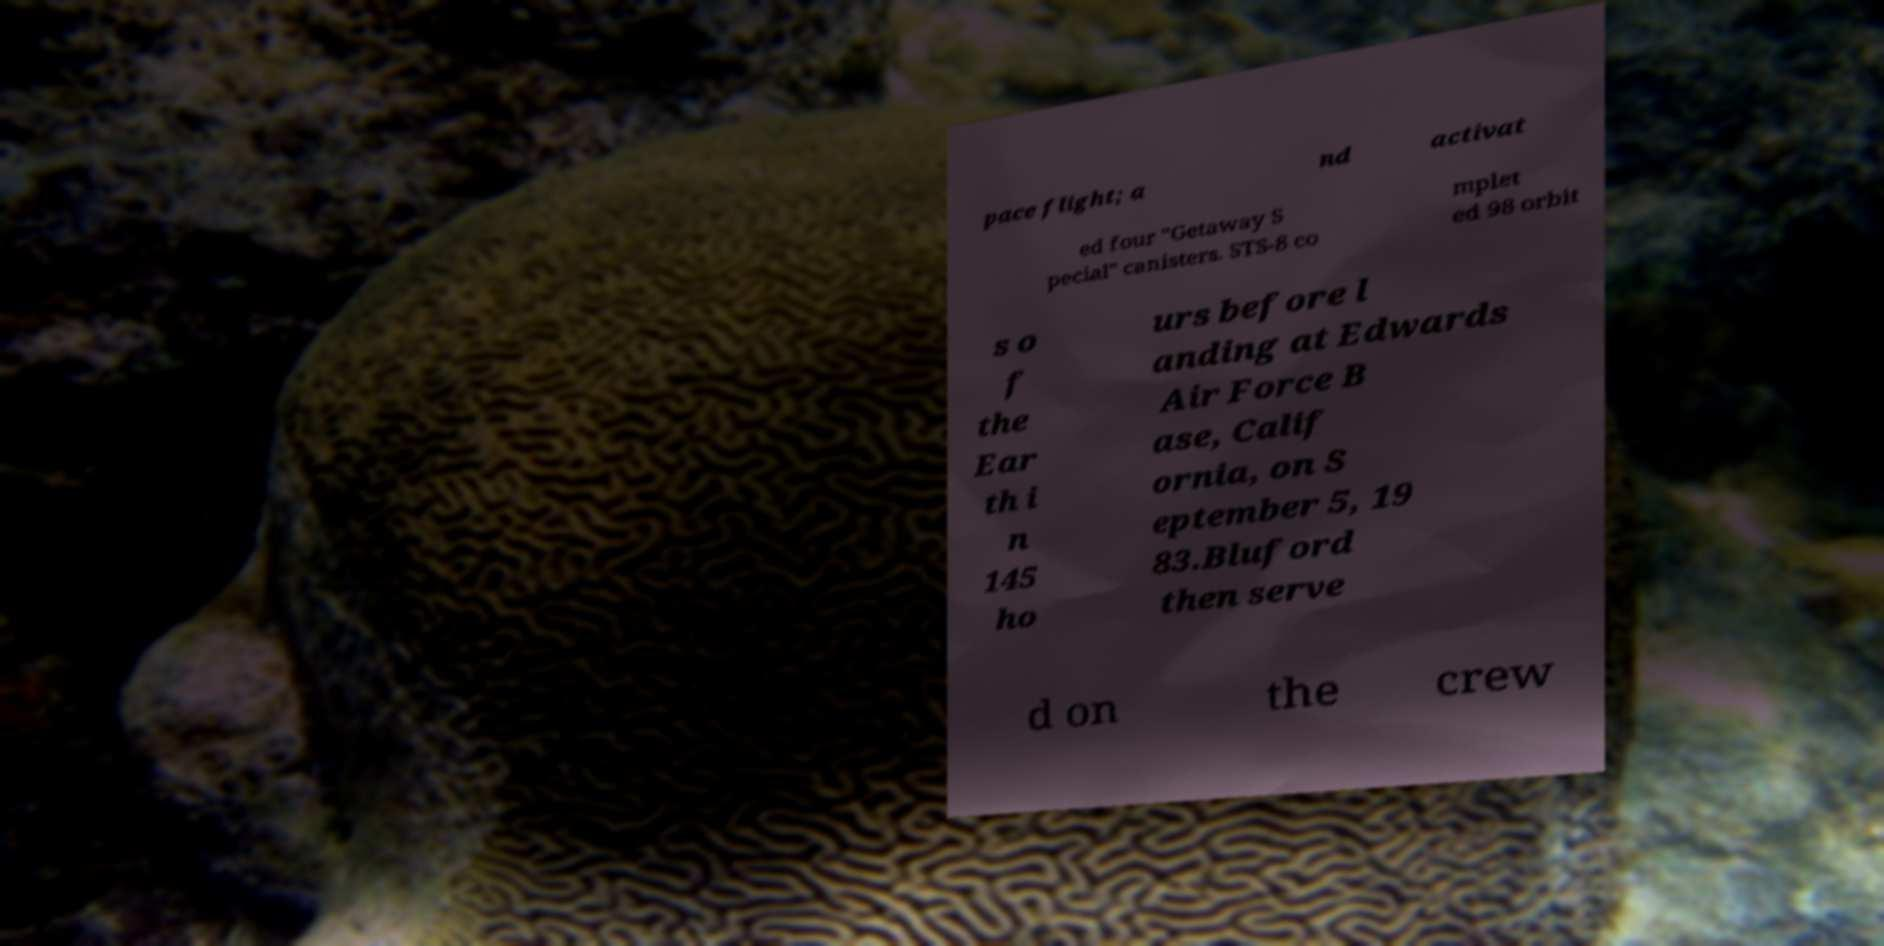For documentation purposes, I need the text within this image transcribed. Could you provide that? pace flight; a nd activat ed four "Getaway S pecial" canisters. STS-8 co mplet ed 98 orbit s o f the Ear th i n 145 ho urs before l anding at Edwards Air Force B ase, Calif ornia, on S eptember 5, 19 83.Bluford then serve d on the crew 